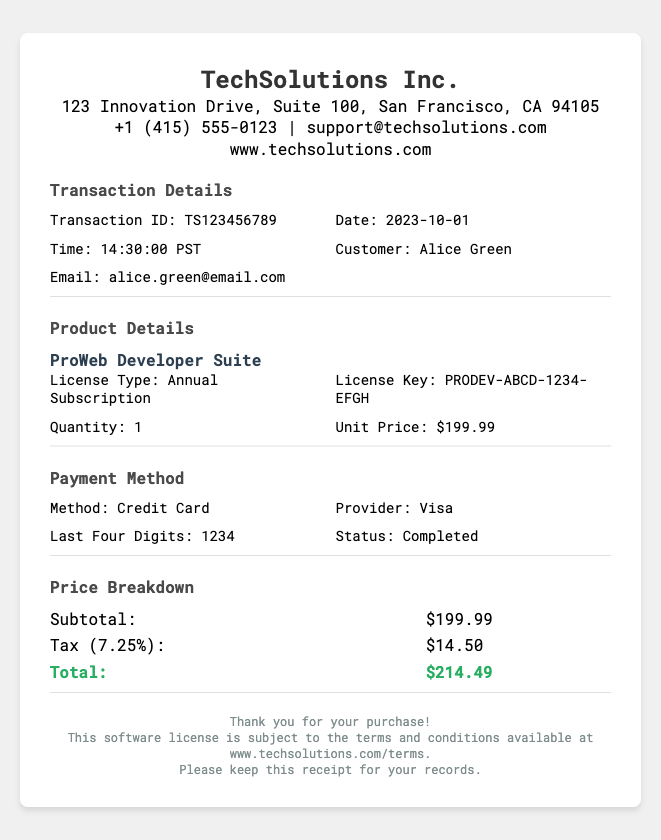What is the transaction ID? The transaction ID is listed in the document under Transaction Details as TS123456789.
Answer: TS123456789 Who was the customer? The customer's name is provided in the Transaction Details section as Alice Green.
Answer: Alice Green What is the unit price of the software license? The document specifies the unit price under Product Details, which is $199.99.
Answer: $199.99 What is the total amount charged? The total amount is the final price under Price Breakdown, which includes the subtotal and tax, as $214.49.
Answer: $214.49 What is the tax rate applied? The tax rate is noted in the Price Breakdown section as 7.25%.
Answer: 7.25% What type of license was purchased? The type of license is mentioned in the Product Details as an Annual Subscription.
Answer: Annual Subscription What payment method was used? The payment method is described in the Payment Method section, which notes that a Credit Card was used.
Answer: Credit Card What are the last four digits of the credit card? The document specifies the last four digits under Payment Method as 1234.
Answer: 1234 What is the company name of the seller? The seller's name is listed at the top of the receipt, which is TechSolutions Inc.
Answer: TechSolutions Inc 